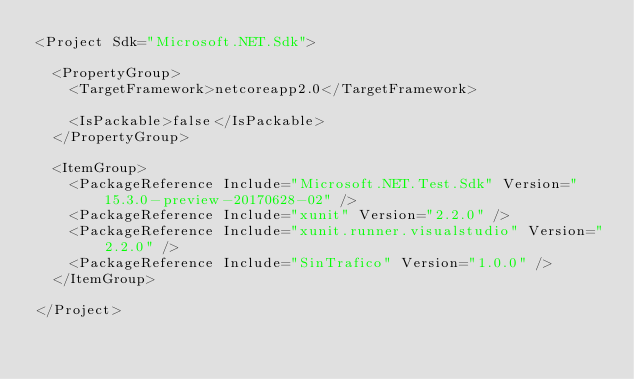<code> <loc_0><loc_0><loc_500><loc_500><_XML_><Project Sdk="Microsoft.NET.Sdk">

  <PropertyGroup>
    <TargetFramework>netcoreapp2.0</TargetFramework>

    <IsPackable>false</IsPackable>
  </PropertyGroup>

  <ItemGroup>
    <PackageReference Include="Microsoft.NET.Test.Sdk" Version="15.3.0-preview-20170628-02" />
    <PackageReference Include="xunit" Version="2.2.0" />
    <PackageReference Include="xunit.runner.visualstudio" Version="2.2.0" />
    <PackageReference Include="SinTrafico" Version="1.0.0" />
  </ItemGroup>

</Project>
</code> 